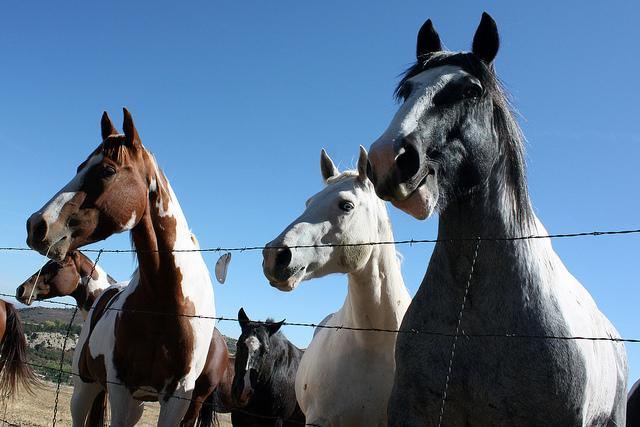What kind of fencing is used around these horses to keep them confined?

Choices:
A) iron
B) link
C) electrified
D) wood electrified 